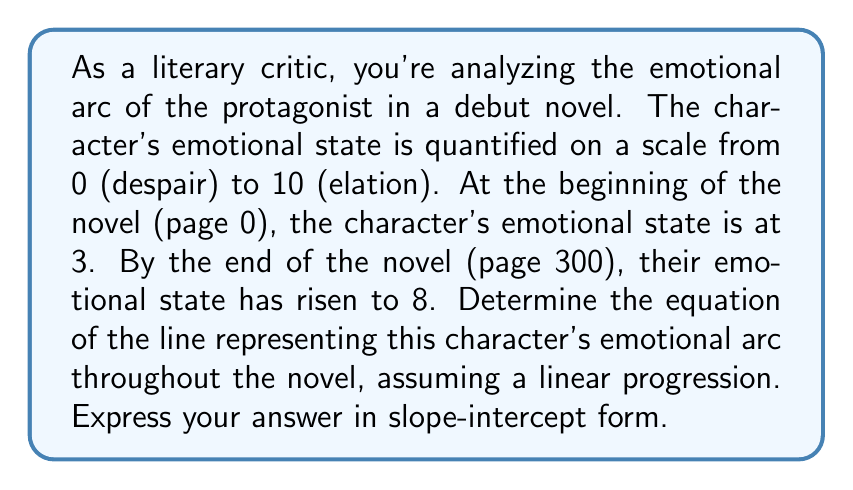Provide a solution to this math problem. To determine the equation of the line representing the character's emotional arc, we'll use the point-slope form of a line and then convert it to slope-intercept form. Let's approach this step-by-step:

1. Identify the two points:
   Point 1: $(x_1, y_1) = (0, 3)$ (beginning of the novel)
   Point 2: $(x_2, y_2) = (300, 8)$ (end of the novel)

2. Calculate the slope (m) of the line:
   $$m = \frac{y_2 - y_1}{x_2 - x_1} = \frac{8 - 3}{300 - 0} = \frac{5}{300} = \frac{1}{60}$$

3. Use the point-slope form of a line with the first point $(0, 3)$:
   $$(y - y_1) = m(x - x_1)$$
   $$(y - 3) = \frac{1}{60}(x - 0)$$

4. Simplify:
   $$y - 3 = \frac{1}{60}x$$

5. Solve for y to get the slope-intercept form $(y = mx + b)$:
   $$y = \frac{1}{60}x + 3$$

This equation represents the character's emotional arc throughout the novel, where $x$ is the page number and $y$ is the emotional state on the scale from 0 to 10.
Answer: $y = \frac{1}{60}x + 3$ 